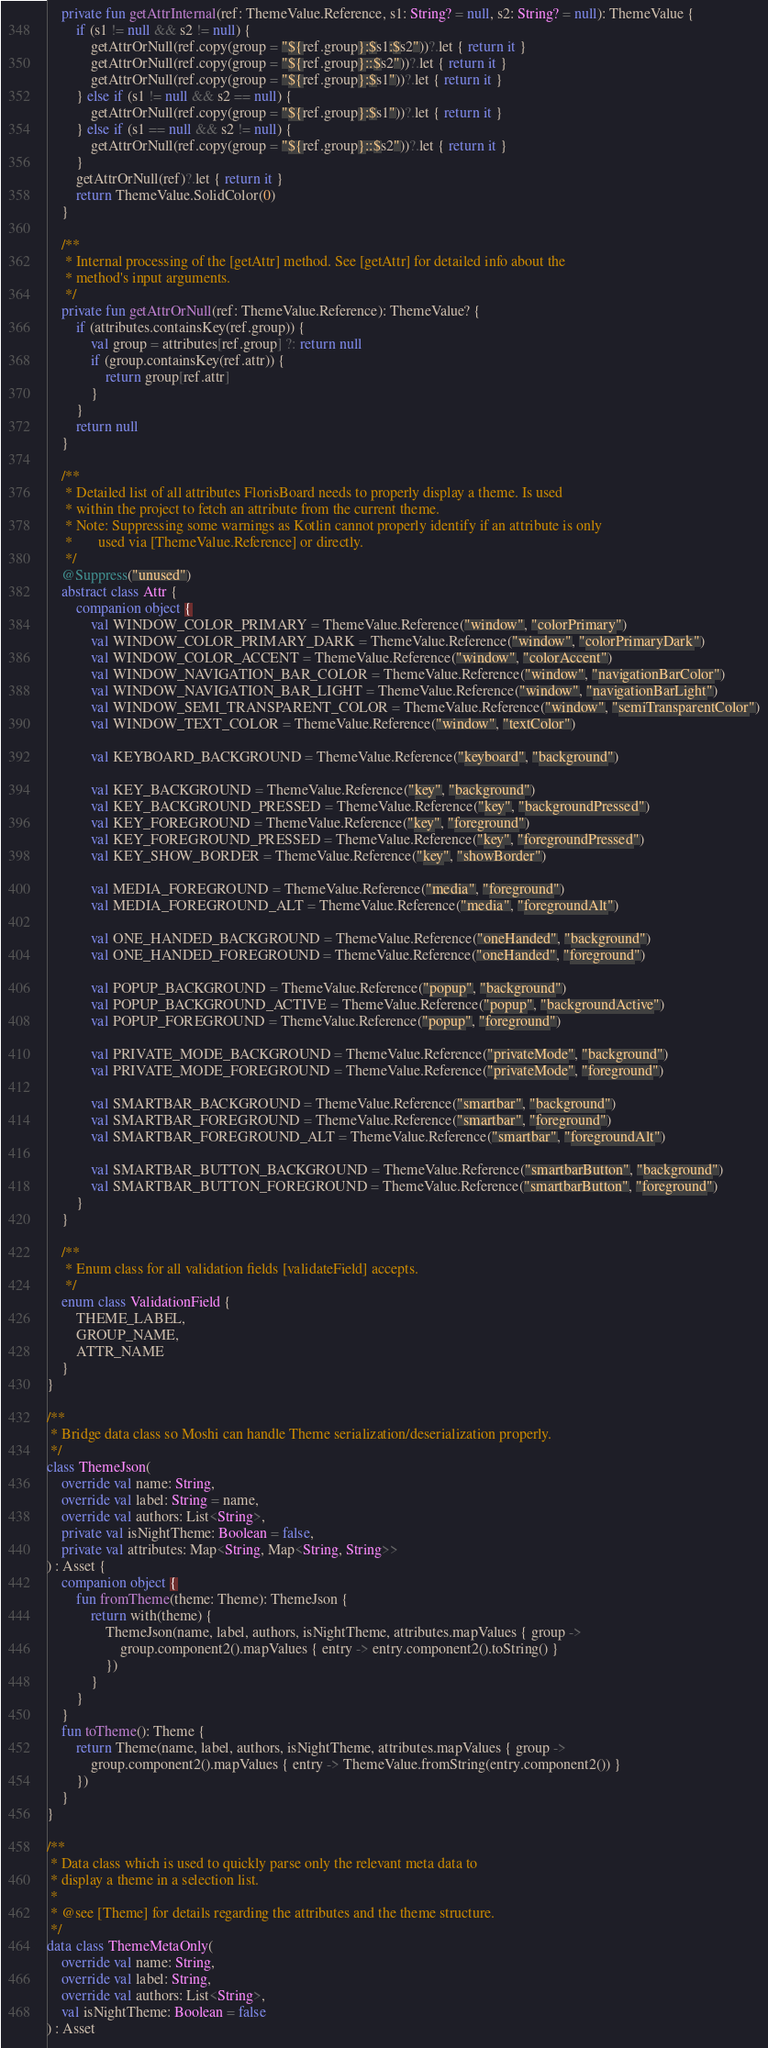<code> <loc_0><loc_0><loc_500><loc_500><_Kotlin_>    private fun getAttrInternal(ref: ThemeValue.Reference, s1: String? = null, s2: String? = null): ThemeValue {
        if (s1 != null && s2 != null) {
            getAttrOrNull(ref.copy(group = "${ref.group}:$s1:$s2"))?.let { return it }
            getAttrOrNull(ref.copy(group = "${ref.group}::$s2"))?.let { return it }
            getAttrOrNull(ref.copy(group = "${ref.group}:$s1"))?.let { return it }
        } else if (s1 != null && s2 == null) {
            getAttrOrNull(ref.copy(group = "${ref.group}:$s1"))?.let { return it }
        } else if (s1 == null && s2 != null) {
            getAttrOrNull(ref.copy(group = "${ref.group}::$s2"))?.let { return it }
        }
        getAttrOrNull(ref)?.let { return it }
        return ThemeValue.SolidColor(0)
    }

    /**
     * Internal processing of the [getAttr] method. See [getAttr] for detailed info about the
     * method's input arguments.
     */
    private fun getAttrOrNull(ref: ThemeValue.Reference): ThemeValue? {
        if (attributes.containsKey(ref.group)) {
            val group = attributes[ref.group] ?: return null
            if (group.containsKey(ref.attr)) {
                return group[ref.attr]
            }
        }
        return null
    }

    /**
     * Detailed list of all attributes FlorisBoard needs to properly display a theme. Is used
     * within the project to fetch an attribute from the current theme.
     * Note: Suppressing some warnings as Kotlin cannot properly identify if an attribute is only
     *       used via [ThemeValue.Reference] or directly.
     */
    @Suppress("unused")
    abstract class Attr {
        companion object {
            val WINDOW_COLOR_PRIMARY = ThemeValue.Reference("window", "colorPrimary")
            val WINDOW_COLOR_PRIMARY_DARK = ThemeValue.Reference("window", "colorPrimaryDark")
            val WINDOW_COLOR_ACCENT = ThemeValue.Reference("window", "colorAccent")
            val WINDOW_NAVIGATION_BAR_COLOR = ThemeValue.Reference("window", "navigationBarColor")
            val WINDOW_NAVIGATION_BAR_LIGHT = ThemeValue.Reference("window", "navigationBarLight")
            val WINDOW_SEMI_TRANSPARENT_COLOR = ThemeValue.Reference("window", "semiTransparentColor")
            val WINDOW_TEXT_COLOR = ThemeValue.Reference("window", "textColor")

            val KEYBOARD_BACKGROUND = ThemeValue.Reference("keyboard", "background")

            val KEY_BACKGROUND = ThemeValue.Reference("key", "background")
            val KEY_BACKGROUND_PRESSED = ThemeValue.Reference("key", "backgroundPressed")
            val KEY_FOREGROUND = ThemeValue.Reference("key", "foreground")
            val KEY_FOREGROUND_PRESSED = ThemeValue.Reference("key", "foregroundPressed")
            val KEY_SHOW_BORDER = ThemeValue.Reference("key", "showBorder")

            val MEDIA_FOREGROUND = ThemeValue.Reference("media", "foreground")
            val MEDIA_FOREGROUND_ALT = ThemeValue.Reference("media", "foregroundAlt")

            val ONE_HANDED_BACKGROUND = ThemeValue.Reference("oneHanded", "background")
            val ONE_HANDED_FOREGROUND = ThemeValue.Reference("oneHanded", "foreground")

            val POPUP_BACKGROUND = ThemeValue.Reference("popup", "background")
            val POPUP_BACKGROUND_ACTIVE = ThemeValue.Reference("popup", "backgroundActive")
            val POPUP_FOREGROUND = ThemeValue.Reference("popup", "foreground")

            val PRIVATE_MODE_BACKGROUND = ThemeValue.Reference("privateMode", "background")
            val PRIVATE_MODE_FOREGROUND = ThemeValue.Reference("privateMode", "foreground")

            val SMARTBAR_BACKGROUND = ThemeValue.Reference("smartbar", "background")
            val SMARTBAR_FOREGROUND = ThemeValue.Reference("smartbar", "foreground")
            val SMARTBAR_FOREGROUND_ALT = ThemeValue.Reference("smartbar", "foregroundAlt")

            val SMARTBAR_BUTTON_BACKGROUND = ThemeValue.Reference("smartbarButton", "background")
            val SMARTBAR_BUTTON_FOREGROUND = ThemeValue.Reference("smartbarButton", "foreground")
        }
    }

    /**
     * Enum class for all validation fields [validateField] accepts.
     */
    enum class ValidationField {
        THEME_LABEL,
        GROUP_NAME,
        ATTR_NAME
    }
}

/**
 * Bridge data class so Moshi can handle Theme serialization/deserialization properly.
 */
class ThemeJson(
    override val name: String,
    override val label: String = name,
    override val authors: List<String>,
    private val isNightTheme: Boolean = false,
    private val attributes: Map<String, Map<String, String>>
) : Asset {
    companion object {
        fun fromTheme(theme: Theme): ThemeJson {
            return with(theme) {
                ThemeJson(name, label, authors, isNightTheme, attributes.mapValues { group ->
                    group.component2().mapValues { entry -> entry.component2().toString() }
                })
            }
        }
    }
    fun toTheme(): Theme {
        return Theme(name, label, authors, isNightTheme, attributes.mapValues { group ->
            group.component2().mapValues { entry -> ThemeValue.fromString(entry.component2()) }
        })
    }
}

/**
 * Data class which is used to quickly parse only the relevant meta data to
 * display a theme in a selection list.
 *
 * @see [Theme] for details regarding the attributes and the theme structure.
 */
data class ThemeMetaOnly(
    override val name: String,
    override val label: String,
    override val authors: List<String>,
    val isNightTheme: Boolean = false
) : Asset
</code> 